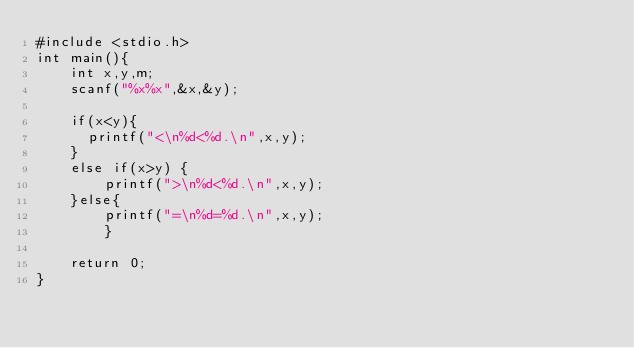<code> <loc_0><loc_0><loc_500><loc_500><_C_>#include <stdio.h>
int main(){
    int x,y,m;
    scanf("%x%x",&x,&y);

    if(x<y){
      printf("<\n%d<%d.\n",x,y);
    }
    else if(x>y) {
        printf(">\n%d<%d.\n",x,y);
    }else{
        printf("=\n%d=%d.\n",x,y);
        }

    return 0;
}</code> 